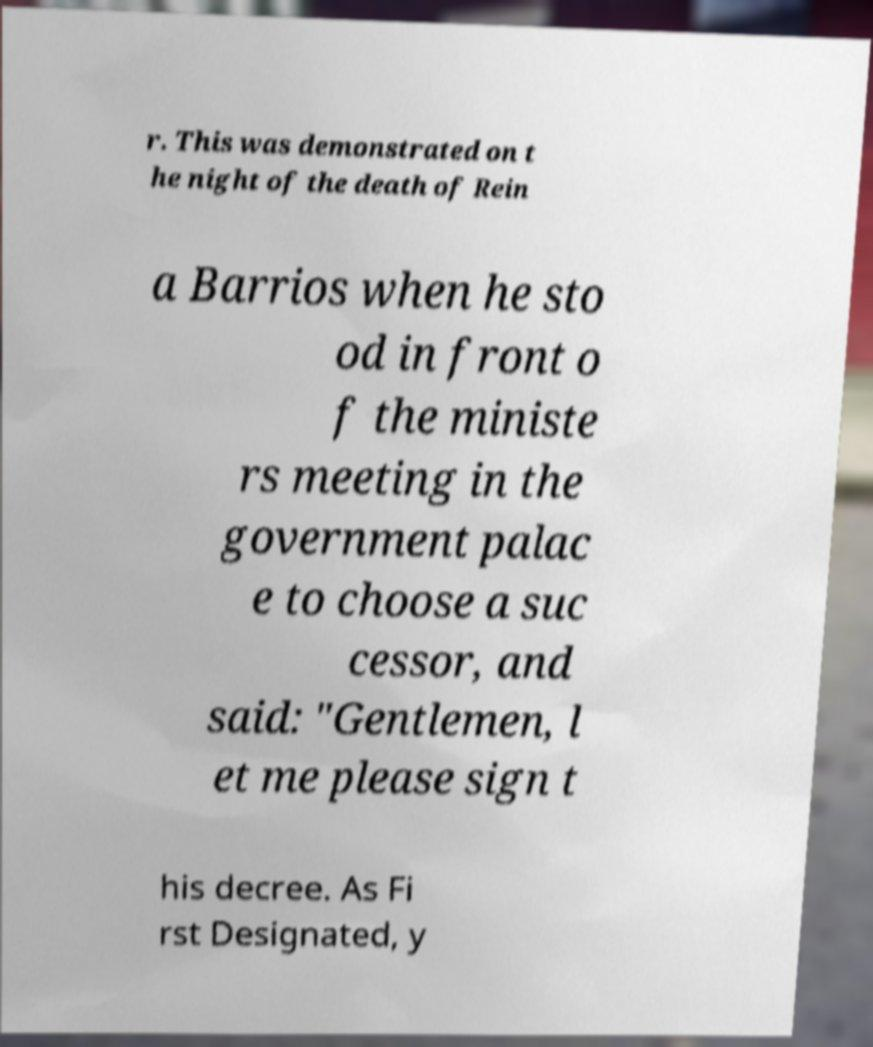Please identify and transcribe the text found in this image. r. This was demonstrated on t he night of the death of Rein a Barrios when he sto od in front o f the ministe rs meeting in the government palac e to choose a suc cessor, and said: "Gentlemen, l et me please sign t his decree. As Fi rst Designated, y 